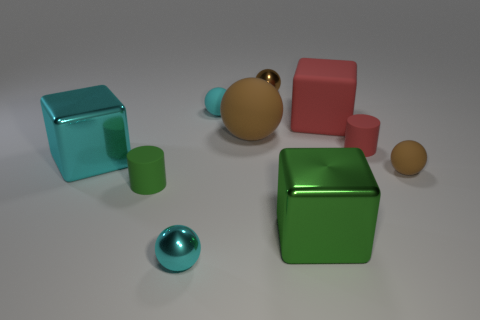Are there any other things of the same color as the matte cube?
Your answer should be very brief. Yes. There is a thing that is in front of the tiny green cylinder and to the left of the green cube; what size is it?
Your answer should be very brief. Small. What material is the large red thing that is behind the red cylinder?
Offer a very short reply. Rubber. Are there any red shiny things of the same shape as the big cyan metallic object?
Provide a short and direct response. No. What number of other matte things have the same shape as the big green object?
Offer a terse response. 1. There is a object that is right of the tiny red object; is it the same size as the cyan ball in front of the small red cylinder?
Make the answer very short. Yes. What is the shape of the large red matte object in front of the small rubber thing behind the large ball?
Offer a terse response. Cube. Are there an equal number of blocks that are behind the tiny brown rubber thing and large objects?
Keep it short and to the point. No. The small brown object that is in front of the small cyan object that is behind the large red matte cube behind the big brown ball is made of what material?
Offer a terse response. Rubber. Is there a green shiny block that has the same size as the red rubber cube?
Your response must be concise. Yes. 